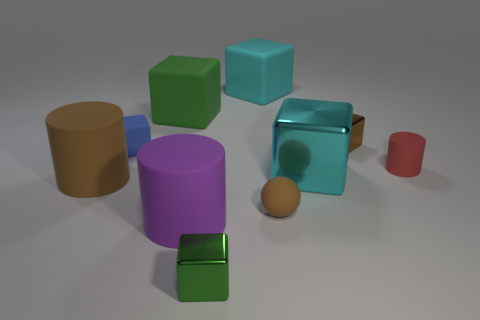Is there any other thing that is the same shape as the small brown matte thing?
Your response must be concise. No. Are there more blue cubes left of the tiny blue matte thing than tiny red cylinders?
Give a very brief answer. No. What color is the metal thing that is right of the large cyan block in front of the tiny brown metallic thing?
Your response must be concise. Brown. What is the shape of the cyan matte thing that is the same size as the green matte thing?
Give a very brief answer. Cube. There is a tiny object that is the same color as the tiny ball; what is its shape?
Provide a succinct answer. Cube. Are there an equal number of small matte cylinders in front of the small green block and purple rubber objects?
Provide a succinct answer. No. What is the material of the tiny object behind the tiny thing that is to the left of the green block behind the small blue matte cube?
Your answer should be compact. Metal. The big cyan thing that is made of the same material as the small green thing is what shape?
Keep it short and to the point. Cube. Are there any other things that are the same color as the tiny rubber cylinder?
Offer a terse response. No. There is a brown rubber object that is on the left side of the cyan block behind the red rubber object; what number of green objects are behind it?
Give a very brief answer. 1. 